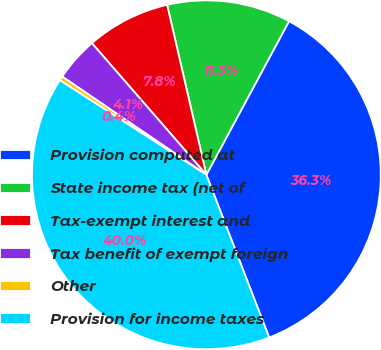<chart> <loc_0><loc_0><loc_500><loc_500><pie_chart><fcel>Provision computed at<fcel>State income tax (net of<fcel>Tax-exempt interest and<fcel>Tax benefit of exempt foreign<fcel>Other<fcel>Provision for income taxes<nl><fcel>36.28%<fcel>11.47%<fcel>7.78%<fcel>4.09%<fcel>0.4%<fcel>39.98%<nl></chart> 